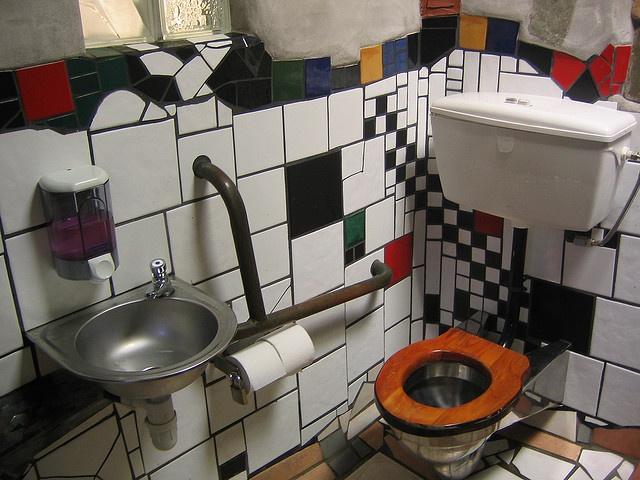Describe the objects in this image and their specific colors. I can see toilet in gray, black, and brown tones and sink in gray, black, and darkgray tones in this image. 